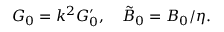<formula> <loc_0><loc_0><loc_500><loc_500>G _ { 0 } = k ^ { 2 } G _ { 0 } ^ { \prime } , \quad \tilde { B } _ { 0 } = B _ { 0 } / \eta .</formula> 